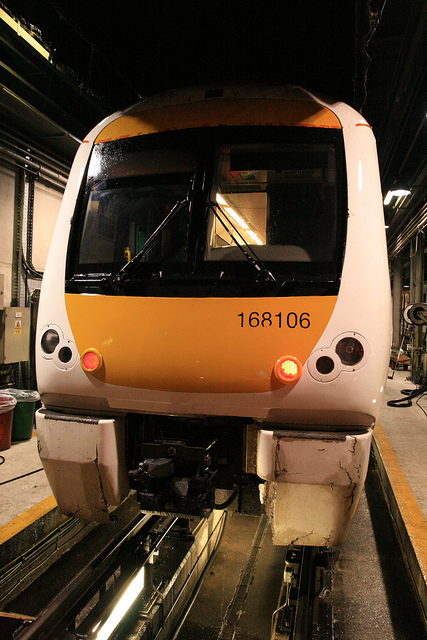Identify and read out the text in this image. 168106 